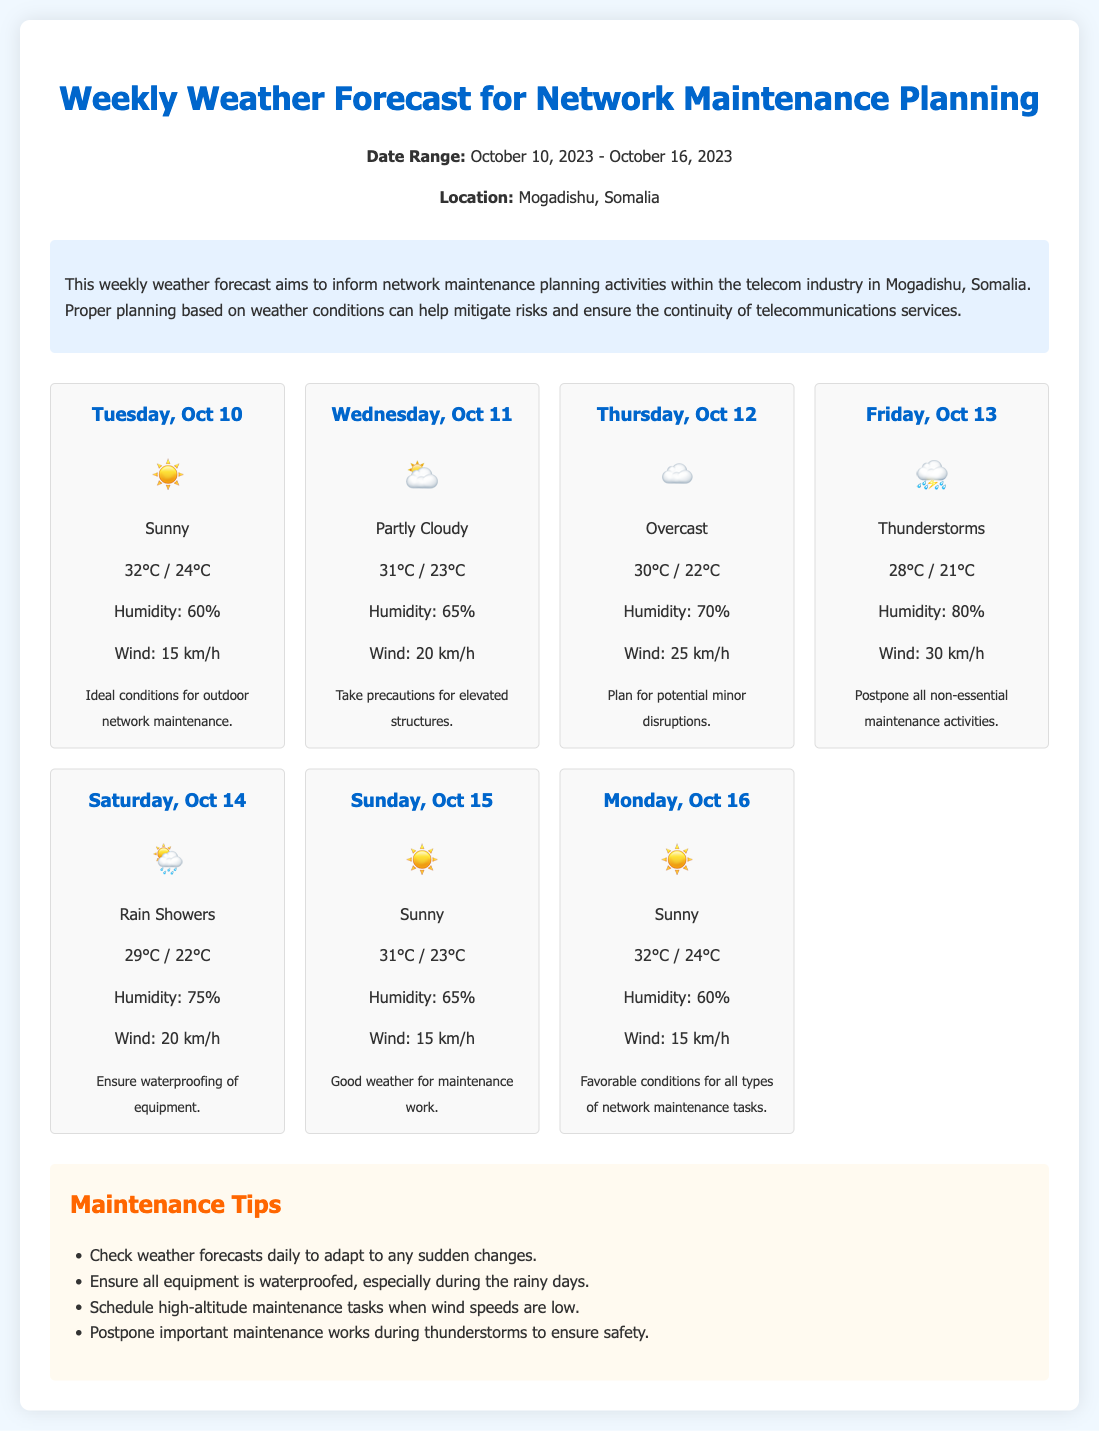What is the date range of the forecast? The date range is specified at the top of the document, covering from October 10, 2023, to October 16, 2023.
Answer: October 10, 2023 - October 16, 2023 What is the highest temperature forecasted for the week? The highest temperature is listed in the forecast for Tuesday, October 10, which states 32°C.
Answer: 32°C On which day are thunderstorms expected? The document indicates thunderstorms are forecasted for Friday, October 13.
Answer: Friday, October 13 What is the recommendation for Friday, October 13? The advice given for that day suggests postponing all non-essential maintenance activities due to thunderstorms.
Answer: Postpone all non-essential maintenance activities How many days during the week are sunny? The document identifies sunny conditions on Tuesday, October 10, Sunday, October 15, and Monday, October 16.
Answer: 3 days What is the humidity level on Saturday, October 14? The forecast card for Saturday, October 14, states the humidity will be at 75%.
Answer: 75% What precautions are advised for elevated structures? The document advises taking precautions for elevated structures on Wednesday, October 11, which is partly cloudy.
Answer: Take precautions for elevated structures What type of weather is expected on Thursday, October 12? The forecast indicates that the weather will be overcast on Thursday, October 12.
Answer: Overcast What action should be taken during thunderstorms? The document specifically recommends postponing important maintenance works during thunderstorms to ensure safety.
Answer: Postpone important maintenance works during thunderstorms 